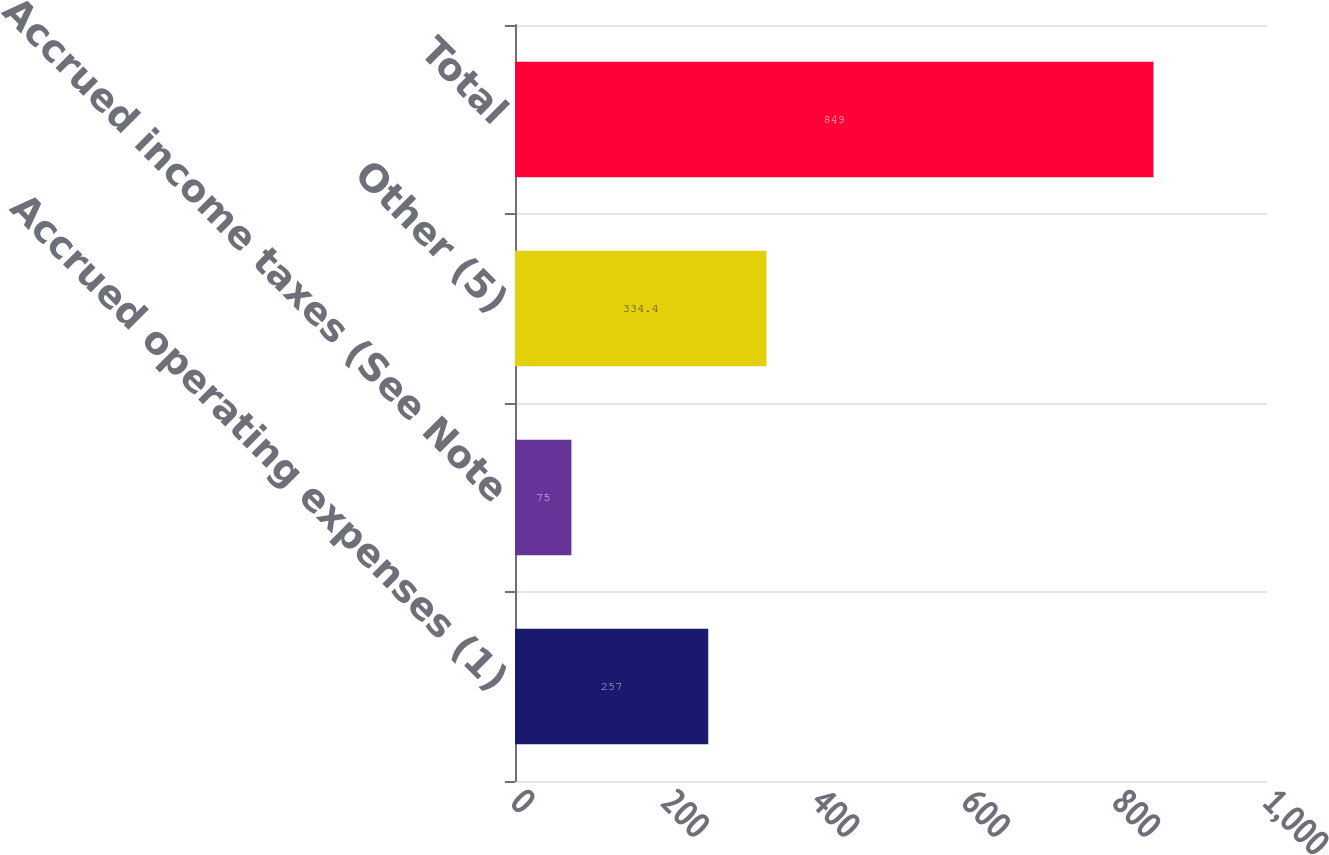Convert chart to OTSL. <chart><loc_0><loc_0><loc_500><loc_500><bar_chart><fcel>Accrued operating expenses (1)<fcel>Accrued income taxes (See Note<fcel>Other (5)<fcel>Total<nl><fcel>257<fcel>75<fcel>334.4<fcel>849<nl></chart> 